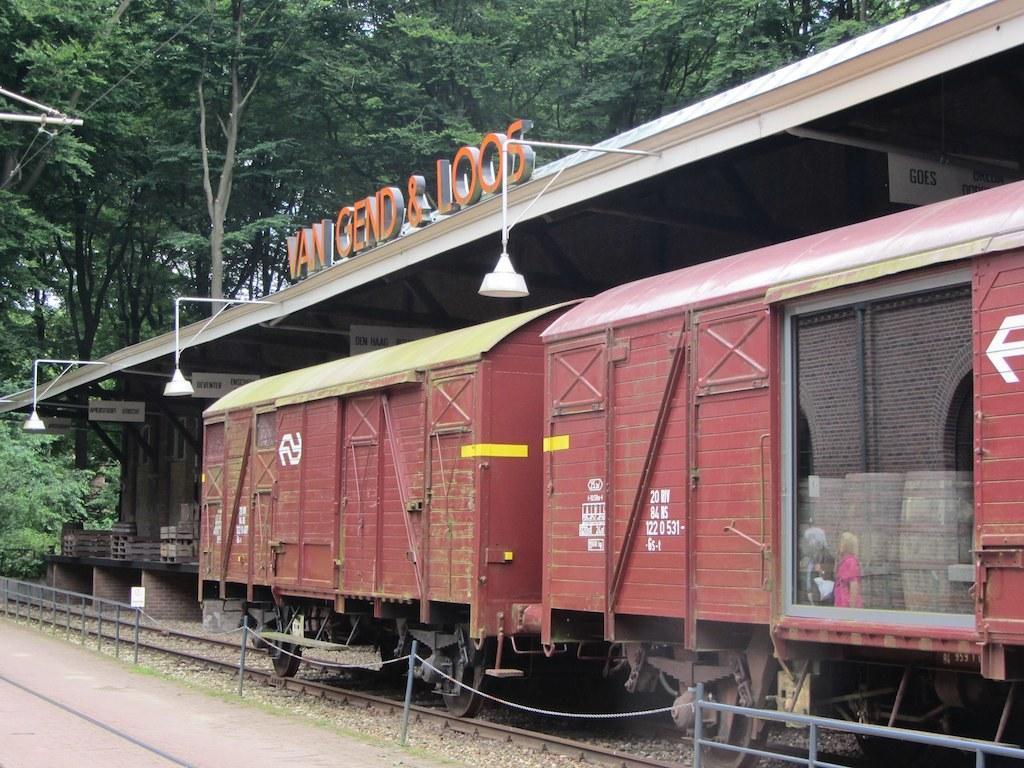In one or two sentences, can you explain what this image depicts? In this picture we can see a railway track and some stones at the bottom, on the right side there is a train and a platform, we can see three lights in the middle, in the background there are some trees, on the left side we can see some wires. 